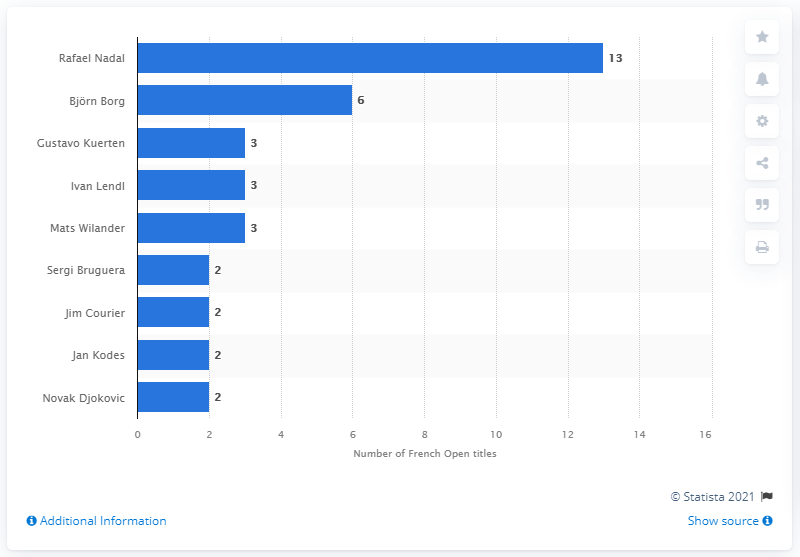Mention a couple of crucial points in this snapshot. Rafael Nadal has won the French Open a record 13 times, making him the most successful player in the history of the tournament. 